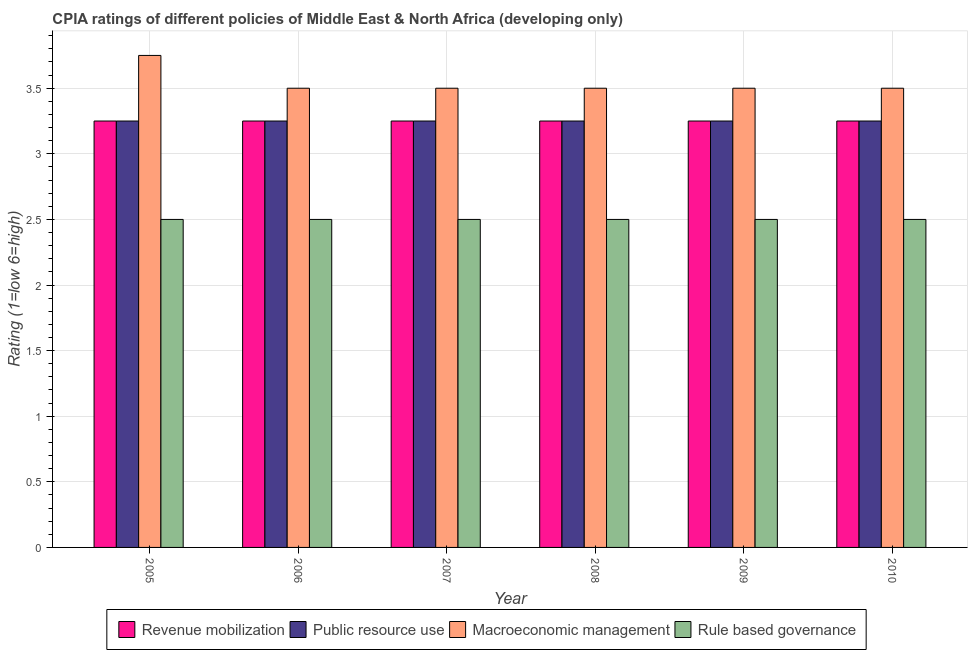How many groups of bars are there?
Make the answer very short. 6. How many bars are there on the 2nd tick from the left?
Your response must be concise. 4. What is the label of the 2nd group of bars from the left?
Provide a succinct answer. 2006. What is the cpia rating of macroeconomic management in 2010?
Offer a terse response. 3.5. Across all years, what is the maximum cpia rating of macroeconomic management?
Your answer should be compact. 3.75. In which year was the cpia rating of public resource use maximum?
Your answer should be very brief. 2005. In which year was the cpia rating of macroeconomic management minimum?
Your answer should be very brief. 2006. What is the total cpia rating of rule based governance in the graph?
Offer a very short reply. 15. What is the difference between the cpia rating of revenue mobilization in 2009 and that in 2010?
Ensure brevity in your answer.  0. What is the difference between the cpia rating of rule based governance in 2010 and the cpia rating of public resource use in 2007?
Your answer should be very brief. 0. What is the average cpia rating of rule based governance per year?
Offer a very short reply. 2.5. What is the difference between the highest and the lowest cpia rating of revenue mobilization?
Your answer should be compact. 0. In how many years, is the cpia rating of rule based governance greater than the average cpia rating of rule based governance taken over all years?
Keep it short and to the point. 0. Is the sum of the cpia rating of public resource use in 2006 and 2007 greater than the maximum cpia rating of revenue mobilization across all years?
Keep it short and to the point. Yes. What does the 4th bar from the left in 2008 represents?
Make the answer very short. Rule based governance. What does the 2nd bar from the right in 2010 represents?
Ensure brevity in your answer.  Macroeconomic management. Is it the case that in every year, the sum of the cpia rating of revenue mobilization and cpia rating of public resource use is greater than the cpia rating of macroeconomic management?
Offer a very short reply. Yes. How many bars are there?
Keep it short and to the point. 24. Are all the bars in the graph horizontal?
Ensure brevity in your answer.  No. Does the graph contain any zero values?
Make the answer very short. No. How many legend labels are there?
Offer a terse response. 4. How are the legend labels stacked?
Provide a short and direct response. Horizontal. What is the title of the graph?
Provide a short and direct response. CPIA ratings of different policies of Middle East & North Africa (developing only). What is the label or title of the X-axis?
Make the answer very short. Year. What is the Rating (1=low 6=high) in Revenue mobilization in 2005?
Your response must be concise. 3.25. What is the Rating (1=low 6=high) of Macroeconomic management in 2005?
Your response must be concise. 3.75. What is the Rating (1=low 6=high) of Rule based governance in 2005?
Ensure brevity in your answer.  2.5. What is the Rating (1=low 6=high) of Public resource use in 2006?
Keep it short and to the point. 3.25. What is the Rating (1=low 6=high) of Macroeconomic management in 2006?
Provide a short and direct response. 3.5. What is the Rating (1=low 6=high) in Rule based governance in 2006?
Provide a short and direct response. 2.5. What is the Rating (1=low 6=high) of Public resource use in 2007?
Your answer should be very brief. 3.25. What is the Rating (1=low 6=high) of Revenue mobilization in 2008?
Your answer should be compact. 3.25. What is the Rating (1=low 6=high) of Public resource use in 2008?
Your response must be concise. 3.25. What is the Rating (1=low 6=high) in Rule based governance in 2008?
Your answer should be compact. 2.5. What is the Rating (1=low 6=high) of Public resource use in 2009?
Keep it short and to the point. 3.25. What is the Rating (1=low 6=high) in Macroeconomic management in 2009?
Offer a terse response. 3.5. What is the Rating (1=low 6=high) of Revenue mobilization in 2010?
Offer a very short reply. 3.25. What is the Rating (1=low 6=high) in Public resource use in 2010?
Keep it short and to the point. 3.25. Across all years, what is the maximum Rating (1=low 6=high) in Revenue mobilization?
Give a very brief answer. 3.25. Across all years, what is the maximum Rating (1=low 6=high) of Macroeconomic management?
Make the answer very short. 3.75. Across all years, what is the minimum Rating (1=low 6=high) of Revenue mobilization?
Give a very brief answer. 3.25. Across all years, what is the minimum Rating (1=low 6=high) in Public resource use?
Provide a short and direct response. 3.25. Across all years, what is the minimum Rating (1=low 6=high) of Macroeconomic management?
Keep it short and to the point. 3.5. Across all years, what is the minimum Rating (1=low 6=high) of Rule based governance?
Your answer should be very brief. 2.5. What is the total Rating (1=low 6=high) of Revenue mobilization in the graph?
Provide a succinct answer. 19.5. What is the total Rating (1=low 6=high) of Public resource use in the graph?
Offer a very short reply. 19.5. What is the total Rating (1=low 6=high) in Macroeconomic management in the graph?
Offer a terse response. 21.25. What is the difference between the Rating (1=low 6=high) in Revenue mobilization in 2005 and that in 2006?
Provide a succinct answer. 0. What is the difference between the Rating (1=low 6=high) of Public resource use in 2005 and that in 2006?
Ensure brevity in your answer.  0. What is the difference between the Rating (1=low 6=high) in Rule based governance in 2005 and that in 2007?
Your answer should be very brief. 0. What is the difference between the Rating (1=low 6=high) in Revenue mobilization in 2005 and that in 2008?
Keep it short and to the point. 0. What is the difference between the Rating (1=low 6=high) in Public resource use in 2005 and that in 2008?
Your response must be concise. 0. What is the difference between the Rating (1=low 6=high) in Macroeconomic management in 2005 and that in 2008?
Offer a very short reply. 0.25. What is the difference between the Rating (1=low 6=high) in Revenue mobilization in 2005 and that in 2010?
Provide a succinct answer. 0. What is the difference between the Rating (1=low 6=high) in Rule based governance in 2005 and that in 2010?
Offer a terse response. 0. What is the difference between the Rating (1=low 6=high) of Public resource use in 2006 and that in 2007?
Offer a very short reply. 0. What is the difference between the Rating (1=low 6=high) of Macroeconomic management in 2006 and that in 2007?
Offer a terse response. 0. What is the difference between the Rating (1=low 6=high) of Revenue mobilization in 2006 and that in 2008?
Provide a succinct answer. 0. What is the difference between the Rating (1=low 6=high) in Macroeconomic management in 2006 and that in 2008?
Your answer should be compact. 0. What is the difference between the Rating (1=low 6=high) of Rule based governance in 2006 and that in 2008?
Offer a very short reply. 0. What is the difference between the Rating (1=low 6=high) in Public resource use in 2006 and that in 2009?
Make the answer very short. 0. What is the difference between the Rating (1=low 6=high) in Macroeconomic management in 2006 and that in 2009?
Offer a terse response. 0. What is the difference between the Rating (1=low 6=high) in Rule based governance in 2006 and that in 2009?
Your response must be concise. 0. What is the difference between the Rating (1=low 6=high) of Public resource use in 2006 and that in 2010?
Your response must be concise. 0. What is the difference between the Rating (1=low 6=high) in Macroeconomic management in 2006 and that in 2010?
Offer a very short reply. 0. What is the difference between the Rating (1=low 6=high) of Rule based governance in 2006 and that in 2010?
Your answer should be very brief. 0. What is the difference between the Rating (1=low 6=high) of Public resource use in 2007 and that in 2008?
Provide a succinct answer. 0. What is the difference between the Rating (1=low 6=high) in Macroeconomic management in 2007 and that in 2008?
Make the answer very short. 0. What is the difference between the Rating (1=low 6=high) of Macroeconomic management in 2007 and that in 2009?
Offer a very short reply. 0. What is the difference between the Rating (1=low 6=high) of Rule based governance in 2007 and that in 2009?
Offer a very short reply. 0. What is the difference between the Rating (1=low 6=high) of Revenue mobilization in 2007 and that in 2010?
Your answer should be compact. 0. What is the difference between the Rating (1=low 6=high) of Public resource use in 2007 and that in 2010?
Make the answer very short. 0. What is the difference between the Rating (1=low 6=high) of Macroeconomic management in 2007 and that in 2010?
Your answer should be very brief. 0. What is the difference between the Rating (1=low 6=high) of Rule based governance in 2007 and that in 2010?
Keep it short and to the point. 0. What is the difference between the Rating (1=low 6=high) in Public resource use in 2008 and that in 2009?
Provide a succinct answer. 0. What is the difference between the Rating (1=low 6=high) of Macroeconomic management in 2008 and that in 2009?
Your answer should be very brief. 0. What is the difference between the Rating (1=low 6=high) of Rule based governance in 2008 and that in 2009?
Give a very brief answer. 0. What is the difference between the Rating (1=low 6=high) of Revenue mobilization in 2008 and that in 2010?
Provide a short and direct response. 0. What is the difference between the Rating (1=low 6=high) in Rule based governance in 2008 and that in 2010?
Offer a very short reply. 0. What is the difference between the Rating (1=low 6=high) of Public resource use in 2009 and that in 2010?
Your answer should be very brief. 0. What is the difference between the Rating (1=low 6=high) of Macroeconomic management in 2009 and that in 2010?
Make the answer very short. 0. What is the difference between the Rating (1=low 6=high) in Rule based governance in 2009 and that in 2010?
Keep it short and to the point. 0. What is the difference between the Rating (1=low 6=high) of Revenue mobilization in 2005 and the Rating (1=low 6=high) of Public resource use in 2006?
Your answer should be very brief. 0. What is the difference between the Rating (1=low 6=high) in Public resource use in 2005 and the Rating (1=low 6=high) in Macroeconomic management in 2006?
Provide a short and direct response. -0.25. What is the difference between the Rating (1=low 6=high) of Macroeconomic management in 2005 and the Rating (1=low 6=high) of Rule based governance in 2006?
Give a very brief answer. 1.25. What is the difference between the Rating (1=low 6=high) in Revenue mobilization in 2005 and the Rating (1=low 6=high) in Public resource use in 2007?
Give a very brief answer. 0. What is the difference between the Rating (1=low 6=high) in Revenue mobilization in 2005 and the Rating (1=low 6=high) in Public resource use in 2008?
Make the answer very short. 0. What is the difference between the Rating (1=low 6=high) of Revenue mobilization in 2005 and the Rating (1=low 6=high) of Rule based governance in 2008?
Give a very brief answer. 0.75. What is the difference between the Rating (1=low 6=high) in Public resource use in 2005 and the Rating (1=low 6=high) in Rule based governance in 2008?
Your answer should be very brief. 0.75. What is the difference between the Rating (1=low 6=high) of Revenue mobilization in 2005 and the Rating (1=low 6=high) of Public resource use in 2009?
Make the answer very short. 0. What is the difference between the Rating (1=low 6=high) in Revenue mobilization in 2005 and the Rating (1=low 6=high) in Macroeconomic management in 2009?
Make the answer very short. -0.25. What is the difference between the Rating (1=low 6=high) in Revenue mobilization in 2005 and the Rating (1=low 6=high) in Rule based governance in 2009?
Give a very brief answer. 0.75. What is the difference between the Rating (1=low 6=high) of Public resource use in 2005 and the Rating (1=low 6=high) of Rule based governance in 2010?
Offer a terse response. 0.75. What is the difference between the Rating (1=low 6=high) in Macroeconomic management in 2005 and the Rating (1=low 6=high) in Rule based governance in 2010?
Give a very brief answer. 1.25. What is the difference between the Rating (1=low 6=high) in Revenue mobilization in 2006 and the Rating (1=low 6=high) in Macroeconomic management in 2007?
Ensure brevity in your answer.  -0.25. What is the difference between the Rating (1=low 6=high) in Revenue mobilization in 2006 and the Rating (1=low 6=high) in Public resource use in 2008?
Make the answer very short. 0. What is the difference between the Rating (1=low 6=high) of Revenue mobilization in 2006 and the Rating (1=low 6=high) of Rule based governance in 2008?
Provide a short and direct response. 0.75. What is the difference between the Rating (1=low 6=high) in Public resource use in 2006 and the Rating (1=low 6=high) in Rule based governance in 2008?
Offer a terse response. 0.75. What is the difference between the Rating (1=low 6=high) of Revenue mobilization in 2006 and the Rating (1=low 6=high) of Rule based governance in 2009?
Provide a short and direct response. 0.75. What is the difference between the Rating (1=low 6=high) in Public resource use in 2006 and the Rating (1=low 6=high) in Macroeconomic management in 2009?
Offer a terse response. -0.25. What is the difference between the Rating (1=low 6=high) of Public resource use in 2006 and the Rating (1=low 6=high) of Rule based governance in 2009?
Your response must be concise. 0.75. What is the difference between the Rating (1=low 6=high) of Macroeconomic management in 2006 and the Rating (1=low 6=high) of Rule based governance in 2009?
Provide a short and direct response. 1. What is the difference between the Rating (1=low 6=high) in Revenue mobilization in 2006 and the Rating (1=low 6=high) in Macroeconomic management in 2010?
Your response must be concise. -0.25. What is the difference between the Rating (1=low 6=high) of Revenue mobilization in 2006 and the Rating (1=low 6=high) of Rule based governance in 2010?
Give a very brief answer. 0.75. What is the difference between the Rating (1=low 6=high) of Public resource use in 2006 and the Rating (1=low 6=high) of Macroeconomic management in 2010?
Your answer should be very brief. -0.25. What is the difference between the Rating (1=low 6=high) in Macroeconomic management in 2006 and the Rating (1=low 6=high) in Rule based governance in 2010?
Ensure brevity in your answer.  1. What is the difference between the Rating (1=low 6=high) of Revenue mobilization in 2007 and the Rating (1=low 6=high) of Public resource use in 2008?
Your answer should be compact. 0. What is the difference between the Rating (1=low 6=high) of Revenue mobilization in 2007 and the Rating (1=low 6=high) of Rule based governance in 2008?
Offer a very short reply. 0.75. What is the difference between the Rating (1=low 6=high) in Public resource use in 2007 and the Rating (1=low 6=high) in Macroeconomic management in 2008?
Make the answer very short. -0.25. What is the difference between the Rating (1=low 6=high) in Public resource use in 2007 and the Rating (1=low 6=high) in Rule based governance in 2008?
Give a very brief answer. 0.75. What is the difference between the Rating (1=low 6=high) of Macroeconomic management in 2007 and the Rating (1=low 6=high) of Rule based governance in 2008?
Provide a succinct answer. 1. What is the difference between the Rating (1=low 6=high) of Revenue mobilization in 2007 and the Rating (1=low 6=high) of Public resource use in 2009?
Offer a terse response. 0. What is the difference between the Rating (1=low 6=high) in Public resource use in 2007 and the Rating (1=low 6=high) in Rule based governance in 2009?
Provide a short and direct response. 0.75. What is the difference between the Rating (1=low 6=high) in Revenue mobilization in 2007 and the Rating (1=low 6=high) in Public resource use in 2010?
Provide a short and direct response. 0. What is the difference between the Rating (1=low 6=high) in Public resource use in 2007 and the Rating (1=low 6=high) in Macroeconomic management in 2010?
Ensure brevity in your answer.  -0.25. What is the difference between the Rating (1=low 6=high) in Public resource use in 2007 and the Rating (1=low 6=high) in Rule based governance in 2010?
Keep it short and to the point. 0.75. What is the difference between the Rating (1=low 6=high) in Macroeconomic management in 2007 and the Rating (1=low 6=high) in Rule based governance in 2010?
Keep it short and to the point. 1. What is the difference between the Rating (1=low 6=high) in Revenue mobilization in 2008 and the Rating (1=low 6=high) in Public resource use in 2009?
Your response must be concise. 0. What is the difference between the Rating (1=low 6=high) in Revenue mobilization in 2008 and the Rating (1=low 6=high) in Rule based governance in 2009?
Make the answer very short. 0.75. What is the difference between the Rating (1=low 6=high) of Revenue mobilization in 2008 and the Rating (1=low 6=high) of Macroeconomic management in 2010?
Give a very brief answer. -0.25. What is the difference between the Rating (1=low 6=high) in Macroeconomic management in 2008 and the Rating (1=low 6=high) in Rule based governance in 2010?
Provide a short and direct response. 1. What is the difference between the Rating (1=low 6=high) in Revenue mobilization in 2009 and the Rating (1=low 6=high) in Public resource use in 2010?
Keep it short and to the point. 0. What is the difference between the Rating (1=low 6=high) of Public resource use in 2009 and the Rating (1=low 6=high) of Macroeconomic management in 2010?
Your response must be concise. -0.25. What is the average Rating (1=low 6=high) in Revenue mobilization per year?
Provide a succinct answer. 3.25. What is the average Rating (1=low 6=high) of Public resource use per year?
Your answer should be very brief. 3.25. What is the average Rating (1=low 6=high) of Macroeconomic management per year?
Your answer should be very brief. 3.54. In the year 2005, what is the difference between the Rating (1=low 6=high) of Revenue mobilization and Rating (1=low 6=high) of Public resource use?
Give a very brief answer. 0. In the year 2005, what is the difference between the Rating (1=low 6=high) of Revenue mobilization and Rating (1=low 6=high) of Macroeconomic management?
Give a very brief answer. -0.5. In the year 2005, what is the difference between the Rating (1=low 6=high) of Public resource use and Rating (1=low 6=high) of Rule based governance?
Give a very brief answer. 0.75. In the year 2006, what is the difference between the Rating (1=low 6=high) of Revenue mobilization and Rating (1=low 6=high) of Macroeconomic management?
Your answer should be very brief. -0.25. In the year 2006, what is the difference between the Rating (1=low 6=high) of Revenue mobilization and Rating (1=low 6=high) of Rule based governance?
Your answer should be compact. 0.75. In the year 2006, what is the difference between the Rating (1=low 6=high) in Public resource use and Rating (1=low 6=high) in Rule based governance?
Your answer should be compact. 0.75. In the year 2007, what is the difference between the Rating (1=low 6=high) of Revenue mobilization and Rating (1=low 6=high) of Macroeconomic management?
Provide a succinct answer. -0.25. In the year 2007, what is the difference between the Rating (1=low 6=high) of Macroeconomic management and Rating (1=low 6=high) of Rule based governance?
Provide a succinct answer. 1. In the year 2008, what is the difference between the Rating (1=low 6=high) in Revenue mobilization and Rating (1=low 6=high) in Macroeconomic management?
Your response must be concise. -0.25. In the year 2008, what is the difference between the Rating (1=low 6=high) of Revenue mobilization and Rating (1=low 6=high) of Rule based governance?
Offer a very short reply. 0.75. In the year 2008, what is the difference between the Rating (1=low 6=high) in Public resource use and Rating (1=low 6=high) in Macroeconomic management?
Offer a very short reply. -0.25. In the year 2009, what is the difference between the Rating (1=low 6=high) of Revenue mobilization and Rating (1=low 6=high) of Macroeconomic management?
Your answer should be compact. -0.25. In the year 2009, what is the difference between the Rating (1=low 6=high) of Revenue mobilization and Rating (1=low 6=high) of Rule based governance?
Your response must be concise. 0.75. In the year 2009, what is the difference between the Rating (1=low 6=high) of Public resource use and Rating (1=low 6=high) of Macroeconomic management?
Offer a very short reply. -0.25. In the year 2010, what is the difference between the Rating (1=low 6=high) of Revenue mobilization and Rating (1=low 6=high) of Public resource use?
Offer a terse response. 0. In the year 2010, what is the difference between the Rating (1=low 6=high) in Public resource use and Rating (1=low 6=high) in Rule based governance?
Give a very brief answer. 0.75. What is the ratio of the Rating (1=low 6=high) in Public resource use in 2005 to that in 2006?
Give a very brief answer. 1. What is the ratio of the Rating (1=low 6=high) in Macroeconomic management in 2005 to that in 2006?
Your answer should be very brief. 1.07. What is the ratio of the Rating (1=low 6=high) in Revenue mobilization in 2005 to that in 2007?
Offer a very short reply. 1. What is the ratio of the Rating (1=low 6=high) of Public resource use in 2005 to that in 2007?
Offer a terse response. 1. What is the ratio of the Rating (1=low 6=high) of Macroeconomic management in 2005 to that in 2007?
Provide a short and direct response. 1.07. What is the ratio of the Rating (1=low 6=high) in Rule based governance in 2005 to that in 2007?
Ensure brevity in your answer.  1. What is the ratio of the Rating (1=low 6=high) in Revenue mobilization in 2005 to that in 2008?
Keep it short and to the point. 1. What is the ratio of the Rating (1=low 6=high) of Public resource use in 2005 to that in 2008?
Ensure brevity in your answer.  1. What is the ratio of the Rating (1=low 6=high) in Macroeconomic management in 2005 to that in 2008?
Your answer should be compact. 1.07. What is the ratio of the Rating (1=low 6=high) in Rule based governance in 2005 to that in 2008?
Keep it short and to the point. 1. What is the ratio of the Rating (1=low 6=high) of Revenue mobilization in 2005 to that in 2009?
Provide a short and direct response. 1. What is the ratio of the Rating (1=low 6=high) in Macroeconomic management in 2005 to that in 2009?
Make the answer very short. 1.07. What is the ratio of the Rating (1=low 6=high) of Rule based governance in 2005 to that in 2009?
Offer a terse response. 1. What is the ratio of the Rating (1=low 6=high) in Macroeconomic management in 2005 to that in 2010?
Your response must be concise. 1.07. What is the ratio of the Rating (1=low 6=high) of Rule based governance in 2005 to that in 2010?
Provide a short and direct response. 1. What is the ratio of the Rating (1=low 6=high) of Revenue mobilization in 2006 to that in 2007?
Offer a terse response. 1. What is the ratio of the Rating (1=low 6=high) of Public resource use in 2006 to that in 2007?
Offer a terse response. 1. What is the ratio of the Rating (1=low 6=high) of Rule based governance in 2006 to that in 2007?
Provide a succinct answer. 1. What is the ratio of the Rating (1=low 6=high) of Revenue mobilization in 2006 to that in 2008?
Your response must be concise. 1. What is the ratio of the Rating (1=low 6=high) in Public resource use in 2006 to that in 2008?
Make the answer very short. 1. What is the ratio of the Rating (1=low 6=high) of Rule based governance in 2006 to that in 2008?
Ensure brevity in your answer.  1. What is the ratio of the Rating (1=low 6=high) of Public resource use in 2006 to that in 2009?
Offer a terse response. 1. What is the ratio of the Rating (1=low 6=high) in Macroeconomic management in 2006 to that in 2009?
Your answer should be very brief. 1. What is the ratio of the Rating (1=low 6=high) of Revenue mobilization in 2006 to that in 2010?
Your answer should be very brief. 1. What is the ratio of the Rating (1=low 6=high) of Public resource use in 2006 to that in 2010?
Offer a very short reply. 1. What is the ratio of the Rating (1=low 6=high) of Macroeconomic management in 2006 to that in 2010?
Make the answer very short. 1. What is the ratio of the Rating (1=low 6=high) in Rule based governance in 2006 to that in 2010?
Provide a succinct answer. 1. What is the ratio of the Rating (1=low 6=high) of Revenue mobilization in 2007 to that in 2008?
Your answer should be compact. 1. What is the ratio of the Rating (1=low 6=high) of Public resource use in 2007 to that in 2010?
Your response must be concise. 1. What is the ratio of the Rating (1=low 6=high) in Rule based governance in 2007 to that in 2010?
Ensure brevity in your answer.  1. What is the ratio of the Rating (1=low 6=high) in Revenue mobilization in 2008 to that in 2009?
Offer a terse response. 1. What is the ratio of the Rating (1=low 6=high) of Public resource use in 2008 to that in 2009?
Your answer should be very brief. 1. What is the ratio of the Rating (1=low 6=high) in Macroeconomic management in 2008 to that in 2009?
Offer a terse response. 1. What is the ratio of the Rating (1=low 6=high) of Rule based governance in 2008 to that in 2009?
Ensure brevity in your answer.  1. What is the ratio of the Rating (1=low 6=high) in Revenue mobilization in 2008 to that in 2010?
Provide a short and direct response. 1. What is the ratio of the Rating (1=low 6=high) in Public resource use in 2008 to that in 2010?
Your answer should be very brief. 1. What is the ratio of the Rating (1=low 6=high) in Macroeconomic management in 2008 to that in 2010?
Offer a terse response. 1. What is the ratio of the Rating (1=low 6=high) in Rule based governance in 2008 to that in 2010?
Your response must be concise. 1. What is the ratio of the Rating (1=low 6=high) of Public resource use in 2009 to that in 2010?
Offer a very short reply. 1. What is the ratio of the Rating (1=low 6=high) in Rule based governance in 2009 to that in 2010?
Provide a short and direct response. 1. What is the difference between the highest and the second highest Rating (1=low 6=high) of Public resource use?
Provide a short and direct response. 0. What is the difference between the highest and the lowest Rating (1=low 6=high) in Macroeconomic management?
Keep it short and to the point. 0.25. 